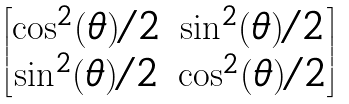Convert formula to latex. <formula><loc_0><loc_0><loc_500><loc_500>\begin{bmatrix} \cos ^ { 2 } ( \theta ) / 2 & \sin ^ { 2 } ( \theta ) / 2 \\ \sin ^ { 2 } ( \theta ) / 2 & \cos ^ { 2 } ( \theta ) / 2 \end{bmatrix}</formula> 